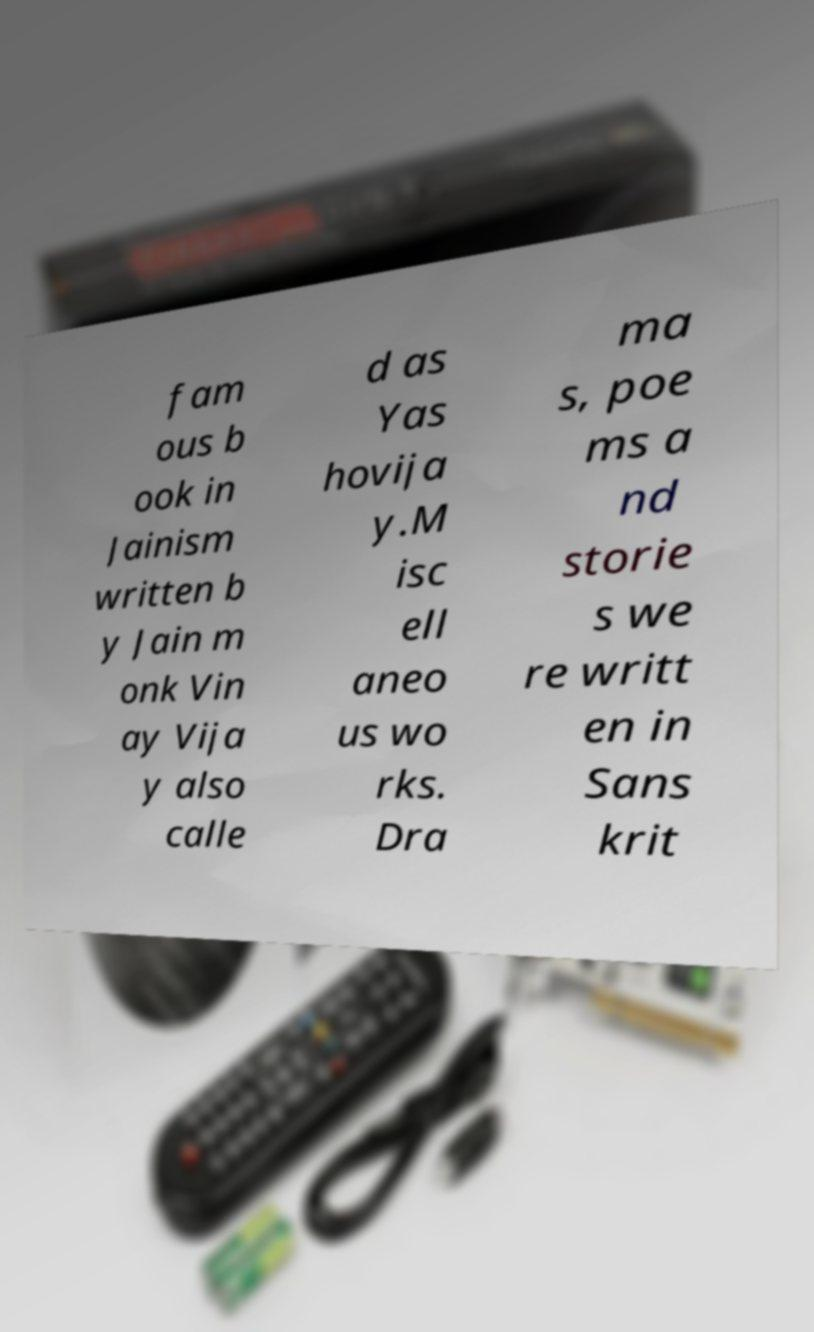I need the written content from this picture converted into text. Can you do that? fam ous b ook in Jainism written b y Jain m onk Vin ay Vija y also calle d as Yas hovija y.M isc ell aneo us wo rks. Dra ma s, poe ms a nd storie s we re writt en in Sans krit 